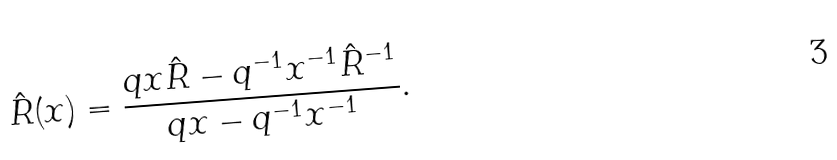Convert formula to latex. <formula><loc_0><loc_0><loc_500><loc_500>\hat { R } ( x ) = \frac { q x \hat { R } - q ^ { - 1 } x ^ { - 1 } \hat { R } ^ { - 1 } } { q x - q ^ { - 1 } x ^ { - 1 } } .</formula> 